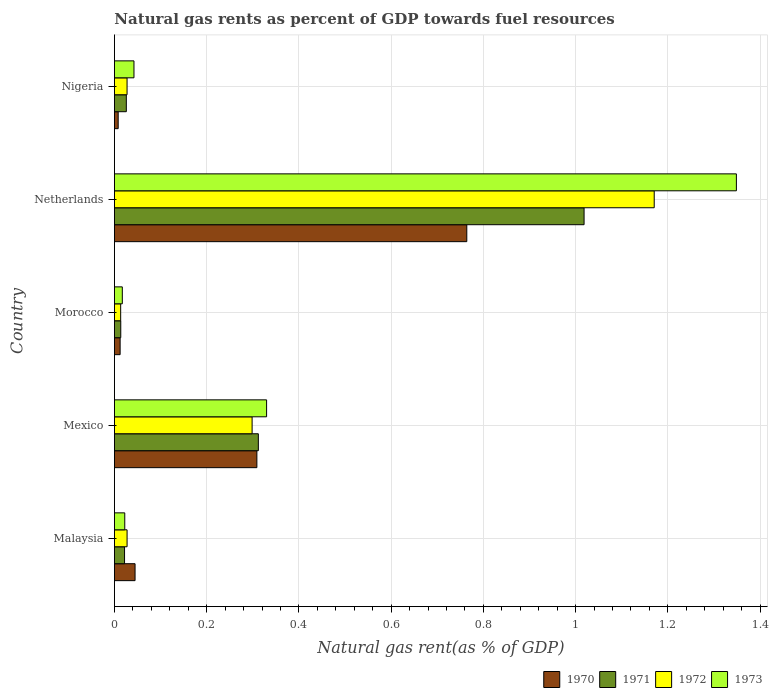Are the number of bars per tick equal to the number of legend labels?
Your answer should be very brief. Yes. How many bars are there on the 1st tick from the top?
Make the answer very short. 4. What is the natural gas rent in 1972 in Morocco?
Provide a short and direct response. 0.01. Across all countries, what is the maximum natural gas rent in 1971?
Provide a succinct answer. 1.02. Across all countries, what is the minimum natural gas rent in 1972?
Your response must be concise. 0.01. In which country was the natural gas rent in 1970 minimum?
Ensure brevity in your answer.  Nigeria. What is the total natural gas rent in 1970 in the graph?
Offer a very short reply. 1.14. What is the difference between the natural gas rent in 1973 in Morocco and that in Nigeria?
Offer a very short reply. -0.03. What is the difference between the natural gas rent in 1973 in Nigeria and the natural gas rent in 1971 in Malaysia?
Your response must be concise. 0.02. What is the average natural gas rent in 1972 per country?
Ensure brevity in your answer.  0.31. What is the difference between the natural gas rent in 1970 and natural gas rent in 1973 in Nigeria?
Offer a terse response. -0.03. In how many countries, is the natural gas rent in 1972 greater than 0.24000000000000002 %?
Make the answer very short. 2. What is the ratio of the natural gas rent in 1972 in Malaysia to that in Mexico?
Provide a short and direct response. 0.09. Is the difference between the natural gas rent in 1970 in Malaysia and Netherlands greater than the difference between the natural gas rent in 1973 in Malaysia and Netherlands?
Provide a short and direct response. Yes. What is the difference between the highest and the second highest natural gas rent in 1972?
Offer a terse response. 0.87. What is the difference between the highest and the lowest natural gas rent in 1972?
Provide a succinct answer. 1.16. Is it the case that in every country, the sum of the natural gas rent in 1971 and natural gas rent in 1973 is greater than the sum of natural gas rent in 1970 and natural gas rent in 1972?
Offer a terse response. No. Is it the case that in every country, the sum of the natural gas rent in 1973 and natural gas rent in 1972 is greater than the natural gas rent in 1971?
Give a very brief answer. Yes. How many bars are there?
Give a very brief answer. 20. Are all the bars in the graph horizontal?
Make the answer very short. Yes. How many countries are there in the graph?
Keep it short and to the point. 5. What is the difference between two consecutive major ticks on the X-axis?
Keep it short and to the point. 0.2. Does the graph contain any zero values?
Your answer should be compact. No. Does the graph contain grids?
Your answer should be very brief. Yes. How many legend labels are there?
Give a very brief answer. 4. What is the title of the graph?
Ensure brevity in your answer.  Natural gas rents as percent of GDP towards fuel resources. Does "1964" appear as one of the legend labels in the graph?
Your response must be concise. No. What is the label or title of the X-axis?
Make the answer very short. Natural gas rent(as % of GDP). What is the Natural gas rent(as % of GDP) of 1970 in Malaysia?
Give a very brief answer. 0.04. What is the Natural gas rent(as % of GDP) of 1971 in Malaysia?
Your answer should be compact. 0.02. What is the Natural gas rent(as % of GDP) of 1972 in Malaysia?
Keep it short and to the point. 0.03. What is the Natural gas rent(as % of GDP) of 1973 in Malaysia?
Give a very brief answer. 0.02. What is the Natural gas rent(as % of GDP) in 1970 in Mexico?
Your response must be concise. 0.31. What is the Natural gas rent(as % of GDP) of 1971 in Mexico?
Make the answer very short. 0.31. What is the Natural gas rent(as % of GDP) in 1972 in Mexico?
Ensure brevity in your answer.  0.3. What is the Natural gas rent(as % of GDP) in 1973 in Mexico?
Provide a short and direct response. 0.33. What is the Natural gas rent(as % of GDP) in 1970 in Morocco?
Ensure brevity in your answer.  0.01. What is the Natural gas rent(as % of GDP) of 1971 in Morocco?
Make the answer very short. 0.01. What is the Natural gas rent(as % of GDP) in 1972 in Morocco?
Provide a succinct answer. 0.01. What is the Natural gas rent(as % of GDP) of 1973 in Morocco?
Your answer should be very brief. 0.02. What is the Natural gas rent(as % of GDP) in 1970 in Netherlands?
Offer a terse response. 0.76. What is the Natural gas rent(as % of GDP) of 1971 in Netherlands?
Provide a short and direct response. 1.02. What is the Natural gas rent(as % of GDP) in 1972 in Netherlands?
Give a very brief answer. 1.17. What is the Natural gas rent(as % of GDP) of 1973 in Netherlands?
Offer a terse response. 1.35. What is the Natural gas rent(as % of GDP) of 1970 in Nigeria?
Make the answer very short. 0.01. What is the Natural gas rent(as % of GDP) in 1971 in Nigeria?
Give a very brief answer. 0.03. What is the Natural gas rent(as % of GDP) in 1972 in Nigeria?
Your answer should be compact. 0.03. What is the Natural gas rent(as % of GDP) of 1973 in Nigeria?
Provide a short and direct response. 0.04. Across all countries, what is the maximum Natural gas rent(as % of GDP) in 1970?
Offer a very short reply. 0.76. Across all countries, what is the maximum Natural gas rent(as % of GDP) in 1971?
Offer a terse response. 1.02. Across all countries, what is the maximum Natural gas rent(as % of GDP) in 1972?
Offer a very short reply. 1.17. Across all countries, what is the maximum Natural gas rent(as % of GDP) in 1973?
Your answer should be compact. 1.35. Across all countries, what is the minimum Natural gas rent(as % of GDP) of 1970?
Your answer should be very brief. 0.01. Across all countries, what is the minimum Natural gas rent(as % of GDP) in 1971?
Make the answer very short. 0.01. Across all countries, what is the minimum Natural gas rent(as % of GDP) in 1972?
Your answer should be compact. 0.01. Across all countries, what is the minimum Natural gas rent(as % of GDP) of 1973?
Provide a succinct answer. 0.02. What is the total Natural gas rent(as % of GDP) of 1970 in the graph?
Your response must be concise. 1.14. What is the total Natural gas rent(as % of GDP) in 1971 in the graph?
Offer a terse response. 1.39. What is the total Natural gas rent(as % of GDP) in 1972 in the graph?
Your answer should be very brief. 1.54. What is the total Natural gas rent(as % of GDP) of 1973 in the graph?
Provide a succinct answer. 1.76. What is the difference between the Natural gas rent(as % of GDP) of 1970 in Malaysia and that in Mexico?
Offer a terse response. -0.26. What is the difference between the Natural gas rent(as % of GDP) in 1971 in Malaysia and that in Mexico?
Your response must be concise. -0.29. What is the difference between the Natural gas rent(as % of GDP) of 1972 in Malaysia and that in Mexico?
Your answer should be compact. -0.27. What is the difference between the Natural gas rent(as % of GDP) in 1973 in Malaysia and that in Mexico?
Keep it short and to the point. -0.31. What is the difference between the Natural gas rent(as % of GDP) in 1970 in Malaysia and that in Morocco?
Make the answer very short. 0.03. What is the difference between the Natural gas rent(as % of GDP) of 1971 in Malaysia and that in Morocco?
Your response must be concise. 0.01. What is the difference between the Natural gas rent(as % of GDP) of 1972 in Malaysia and that in Morocco?
Your answer should be very brief. 0.01. What is the difference between the Natural gas rent(as % of GDP) in 1973 in Malaysia and that in Morocco?
Provide a succinct answer. 0.01. What is the difference between the Natural gas rent(as % of GDP) in 1970 in Malaysia and that in Netherlands?
Provide a short and direct response. -0.72. What is the difference between the Natural gas rent(as % of GDP) of 1971 in Malaysia and that in Netherlands?
Offer a terse response. -1. What is the difference between the Natural gas rent(as % of GDP) in 1972 in Malaysia and that in Netherlands?
Give a very brief answer. -1.14. What is the difference between the Natural gas rent(as % of GDP) of 1973 in Malaysia and that in Netherlands?
Your response must be concise. -1.33. What is the difference between the Natural gas rent(as % of GDP) of 1970 in Malaysia and that in Nigeria?
Your response must be concise. 0.04. What is the difference between the Natural gas rent(as % of GDP) of 1971 in Malaysia and that in Nigeria?
Your response must be concise. -0. What is the difference between the Natural gas rent(as % of GDP) of 1973 in Malaysia and that in Nigeria?
Your response must be concise. -0.02. What is the difference between the Natural gas rent(as % of GDP) of 1970 in Mexico and that in Morocco?
Provide a succinct answer. 0.3. What is the difference between the Natural gas rent(as % of GDP) of 1971 in Mexico and that in Morocco?
Provide a succinct answer. 0.3. What is the difference between the Natural gas rent(as % of GDP) in 1972 in Mexico and that in Morocco?
Keep it short and to the point. 0.28. What is the difference between the Natural gas rent(as % of GDP) of 1973 in Mexico and that in Morocco?
Ensure brevity in your answer.  0.31. What is the difference between the Natural gas rent(as % of GDP) in 1970 in Mexico and that in Netherlands?
Offer a terse response. -0.46. What is the difference between the Natural gas rent(as % of GDP) of 1971 in Mexico and that in Netherlands?
Provide a succinct answer. -0.71. What is the difference between the Natural gas rent(as % of GDP) of 1972 in Mexico and that in Netherlands?
Provide a short and direct response. -0.87. What is the difference between the Natural gas rent(as % of GDP) of 1973 in Mexico and that in Netherlands?
Provide a short and direct response. -1.02. What is the difference between the Natural gas rent(as % of GDP) of 1970 in Mexico and that in Nigeria?
Offer a terse response. 0.3. What is the difference between the Natural gas rent(as % of GDP) of 1971 in Mexico and that in Nigeria?
Make the answer very short. 0.29. What is the difference between the Natural gas rent(as % of GDP) in 1972 in Mexico and that in Nigeria?
Provide a succinct answer. 0.27. What is the difference between the Natural gas rent(as % of GDP) in 1973 in Mexico and that in Nigeria?
Offer a very short reply. 0.29. What is the difference between the Natural gas rent(as % of GDP) of 1970 in Morocco and that in Netherlands?
Provide a succinct answer. -0.75. What is the difference between the Natural gas rent(as % of GDP) in 1971 in Morocco and that in Netherlands?
Your answer should be compact. -1. What is the difference between the Natural gas rent(as % of GDP) of 1972 in Morocco and that in Netherlands?
Give a very brief answer. -1.16. What is the difference between the Natural gas rent(as % of GDP) in 1973 in Morocco and that in Netherlands?
Offer a terse response. -1.33. What is the difference between the Natural gas rent(as % of GDP) in 1970 in Morocco and that in Nigeria?
Ensure brevity in your answer.  0. What is the difference between the Natural gas rent(as % of GDP) in 1971 in Morocco and that in Nigeria?
Give a very brief answer. -0.01. What is the difference between the Natural gas rent(as % of GDP) of 1972 in Morocco and that in Nigeria?
Your response must be concise. -0.01. What is the difference between the Natural gas rent(as % of GDP) of 1973 in Morocco and that in Nigeria?
Your response must be concise. -0.03. What is the difference between the Natural gas rent(as % of GDP) in 1970 in Netherlands and that in Nigeria?
Provide a succinct answer. 0.76. What is the difference between the Natural gas rent(as % of GDP) of 1971 in Netherlands and that in Nigeria?
Provide a succinct answer. 0.99. What is the difference between the Natural gas rent(as % of GDP) of 1972 in Netherlands and that in Nigeria?
Provide a short and direct response. 1.14. What is the difference between the Natural gas rent(as % of GDP) in 1973 in Netherlands and that in Nigeria?
Offer a very short reply. 1.31. What is the difference between the Natural gas rent(as % of GDP) of 1970 in Malaysia and the Natural gas rent(as % of GDP) of 1971 in Mexico?
Ensure brevity in your answer.  -0.27. What is the difference between the Natural gas rent(as % of GDP) in 1970 in Malaysia and the Natural gas rent(as % of GDP) in 1972 in Mexico?
Your answer should be very brief. -0.25. What is the difference between the Natural gas rent(as % of GDP) of 1970 in Malaysia and the Natural gas rent(as % of GDP) of 1973 in Mexico?
Give a very brief answer. -0.29. What is the difference between the Natural gas rent(as % of GDP) of 1971 in Malaysia and the Natural gas rent(as % of GDP) of 1972 in Mexico?
Give a very brief answer. -0.28. What is the difference between the Natural gas rent(as % of GDP) of 1971 in Malaysia and the Natural gas rent(as % of GDP) of 1973 in Mexico?
Make the answer very short. -0.31. What is the difference between the Natural gas rent(as % of GDP) of 1972 in Malaysia and the Natural gas rent(as % of GDP) of 1973 in Mexico?
Your answer should be compact. -0.3. What is the difference between the Natural gas rent(as % of GDP) in 1970 in Malaysia and the Natural gas rent(as % of GDP) in 1971 in Morocco?
Make the answer very short. 0.03. What is the difference between the Natural gas rent(as % of GDP) in 1970 in Malaysia and the Natural gas rent(as % of GDP) in 1972 in Morocco?
Keep it short and to the point. 0.03. What is the difference between the Natural gas rent(as % of GDP) in 1970 in Malaysia and the Natural gas rent(as % of GDP) in 1973 in Morocco?
Your response must be concise. 0.03. What is the difference between the Natural gas rent(as % of GDP) of 1971 in Malaysia and the Natural gas rent(as % of GDP) of 1972 in Morocco?
Offer a terse response. 0.01. What is the difference between the Natural gas rent(as % of GDP) in 1971 in Malaysia and the Natural gas rent(as % of GDP) in 1973 in Morocco?
Provide a short and direct response. 0. What is the difference between the Natural gas rent(as % of GDP) of 1972 in Malaysia and the Natural gas rent(as % of GDP) of 1973 in Morocco?
Offer a very short reply. 0.01. What is the difference between the Natural gas rent(as % of GDP) of 1970 in Malaysia and the Natural gas rent(as % of GDP) of 1971 in Netherlands?
Your answer should be very brief. -0.97. What is the difference between the Natural gas rent(as % of GDP) in 1970 in Malaysia and the Natural gas rent(as % of GDP) in 1972 in Netherlands?
Keep it short and to the point. -1.13. What is the difference between the Natural gas rent(as % of GDP) in 1970 in Malaysia and the Natural gas rent(as % of GDP) in 1973 in Netherlands?
Ensure brevity in your answer.  -1.3. What is the difference between the Natural gas rent(as % of GDP) of 1971 in Malaysia and the Natural gas rent(as % of GDP) of 1972 in Netherlands?
Your answer should be compact. -1.15. What is the difference between the Natural gas rent(as % of GDP) of 1971 in Malaysia and the Natural gas rent(as % of GDP) of 1973 in Netherlands?
Provide a succinct answer. -1.33. What is the difference between the Natural gas rent(as % of GDP) in 1972 in Malaysia and the Natural gas rent(as % of GDP) in 1973 in Netherlands?
Your answer should be compact. -1.32. What is the difference between the Natural gas rent(as % of GDP) in 1970 in Malaysia and the Natural gas rent(as % of GDP) in 1971 in Nigeria?
Keep it short and to the point. 0.02. What is the difference between the Natural gas rent(as % of GDP) of 1970 in Malaysia and the Natural gas rent(as % of GDP) of 1972 in Nigeria?
Your answer should be compact. 0.02. What is the difference between the Natural gas rent(as % of GDP) in 1970 in Malaysia and the Natural gas rent(as % of GDP) in 1973 in Nigeria?
Your answer should be compact. 0. What is the difference between the Natural gas rent(as % of GDP) in 1971 in Malaysia and the Natural gas rent(as % of GDP) in 1972 in Nigeria?
Give a very brief answer. -0.01. What is the difference between the Natural gas rent(as % of GDP) in 1971 in Malaysia and the Natural gas rent(as % of GDP) in 1973 in Nigeria?
Offer a terse response. -0.02. What is the difference between the Natural gas rent(as % of GDP) of 1972 in Malaysia and the Natural gas rent(as % of GDP) of 1973 in Nigeria?
Your answer should be very brief. -0.01. What is the difference between the Natural gas rent(as % of GDP) in 1970 in Mexico and the Natural gas rent(as % of GDP) in 1971 in Morocco?
Make the answer very short. 0.3. What is the difference between the Natural gas rent(as % of GDP) in 1970 in Mexico and the Natural gas rent(as % of GDP) in 1972 in Morocco?
Give a very brief answer. 0.3. What is the difference between the Natural gas rent(as % of GDP) in 1970 in Mexico and the Natural gas rent(as % of GDP) in 1973 in Morocco?
Your answer should be very brief. 0.29. What is the difference between the Natural gas rent(as % of GDP) in 1971 in Mexico and the Natural gas rent(as % of GDP) in 1972 in Morocco?
Offer a very short reply. 0.3. What is the difference between the Natural gas rent(as % of GDP) of 1971 in Mexico and the Natural gas rent(as % of GDP) of 1973 in Morocco?
Give a very brief answer. 0.29. What is the difference between the Natural gas rent(as % of GDP) of 1972 in Mexico and the Natural gas rent(as % of GDP) of 1973 in Morocco?
Offer a terse response. 0.28. What is the difference between the Natural gas rent(as % of GDP) in 1970 in Mexico and the Natural gas rent(as % of GDP) in 1971 in Netherlands?
Give a very brief answer. -0.71. What is the difference between the Natural gas rent(as % of GDP) in 1970 in Mexico and the Natural gas rent(as % of GDP) in 1972 in Netherlands?
Keep it short and to the point. -0.86. What is the difference between the Natural gas rent(as % of GDP) in 1970 in Mexico and the Natural gas rent(as % of GDP) in 1973 in Netherlands?
Provide a succinct answer. -1.04. What is the difference between the Natural gas rent(as % of GDP) in 1971 in Mexico and the Natural gas rent(as % of GDP) in 1972 in Netherlands?
Offer a terse response. -0.86. What is the difference between the Natural gas rent(as % of GDP) in 1971 in Mexico and the Natural gas rent(as % of GDP) in 1973 in Netherlands?
Offer a terse response. -1.04. What is the difference between the Natural gas rent(as % of GDP) of 1972 in Mexico and the Natural gas rent(as % of GDP) of 1973 in Netherlands?
Offer a very short reply. -1.05. What is the difference between the Natural gas rent(as % of GDP) in 1970 in Mexico and the Natural gas rent(as % of GDP) in 1971 in Nigeria?
Offer a very short reply. 0.28. What is the difference between the Natural gas rent(as % of GDP) in 1970 in Mexico and the Natural gas rent(as % of GDP) in 1972 in Nigeria?
Offer a terse response. 0.28. What is the difference between the Natural gas rent(as % of GDP) in 1970 in Mexico and the Natural gas rent(as % of GDP) in 1973 in Nigeria?
Ensure brevity in your answer.  0.27. What is the difference between the Natural gas rent(as % of GDP) in 1971 in Mexico and the Natural gas rent(as % of GDP) in 1972 in Nigeria?
Provide a short and direct response. 0.28. What is the difference between the Natural gas rent(as % of GDP) of 1971 in Mexico and the Natural gas rent(as % of GDP) of 1973 in Nigeria?
Provide a succinct answer. 0.27. What is the difference between the Natural gas rent(as % of GDP) of 1972 in Mexico and the Natural gas rent(as % of GDP) of 1973 in Nigeria?
Offer a terse response. 0.26. What is the difference between the Natural gas rent(as % of GDP) in 1970 in Morocco and the Natural gas rent(as % of GDP) in 1971 in Netherlands?
Offer a very short reply. -1.01. What is the difference between the Natural gas rent(as % of GDP) in 1970 in Morocco and the Natural gas rent(as % of GDP) in 1972 in Netherlands?
Provide a succinct answer. -1.16. What is the difference between the Natural gas rent(as % of GDP) in 1970 in Morocco and the Natural gas rent(as % of GDP) in 1973 in Netherlands?
Offer a very short reply. -1.34. What is the difference between the Natural gas rent(as % of GDP) of 1971 in Morocco and the Natural gas rent(as % of GDP) of 1972 in Netherlands?
Ensure brevity in your answer.  -1.16. What is the difference between the Natural gas rent(as % of GDP) in 1971 in Morocco and the Natural gas rent(as % of GDP) in 1973 in Netherlands?
Ensure brevity in your answer.  -1.33. What is the difference between the Natural gas rent(as % of GDP) in 1972 in Morocco and the Natural gas rent(as % of GDP) in 1973 in Netherlands?
Offer a very short reply. -1.34. What is the difference between the Natural gas rent(as % of GDP) of 1970 in Morocco and the Natural gas rent(as % of GDP) of 1971 in Nigeria?
Provide a short and direct response. -0.01. What is the difference between the Natural gas rent(as % of GDP) in 1970 in Morocco and the Natural gas rent(as % of GDP) in 1972 in Nigeria?
Ensure brevity in your answer.  -0.02. What is the difference between the Natural gas rent(as % of GDP) in 1970 in Morocco and the Natural gas rent(as % of GDP) in 1973 in Nigeria?
Your answer should be compact. -0.03. What is the difference between the Natural gas rent(as % of GDP) in 1971 in Morocco and the Natural gas rent(as % of GDP) in 1972 in Nigeria?
Make the answer very short. -0.01. What is the difference between the Natural gas rent(as % of GDP) of 1971 in Morocco and the Natural gas rent(as % of GDP) of 1973 in Nigeria?
Provide a short and direct response. -0.03. What is the difference between the Natural gas rent(as % of GDP) of 1972 in Morocco and the Natural gas rent(as % of GDP) of 1973 in Nigeria?
Offer a very short reply. -0.03. What is the difference between the Natural gas rent(as % of GDP) in 1970 in Netherlands and the Natural gas rent(as % of GDP) in 1971 in Nigeria?
Provide a succinct answer. 0.74. What is the difference between the Natural gas rent(as % of GDP) of 1970 in Netherlands and the Natural gas rent(as % of GDP) of 1972 in Nigeria?
Keep it short and to the point. 0.74. What is the difference between the Natural gas rent(as % of GDP) of 1970 in Netherlands and the Natural gas rent(as % of GDP) of 1973 in Nigeria?
Give a very brief answer. 0.72. What is the difference between the Natural gas rent(as % of GDP) of 1971 in Netherlands and the Natural gas rent(as % of GDP) of 1972 in Nigeria?
Keep it short and to the point. 0.99. What is the difference between the Natural gas rent(as % of GDP) in 1972 in Netherlands and the Natural gas rent(as % of GDP) in 1973 in Nigeria?
Make the answer very short. 1.13. What is the average Natural gas rent(as % of GDP) of 1970 per country?
Give a very brief answer. 0.23. What is the average Natural gas rent(as % of GDP) of 1971 per country?
Ensure brevity in your answer.  0.28. What is the average Natural gas rent(as % of GDP) of 1972 per country?
Provide a succinct answer. 0.31. What is the average Natural gas rent(as % of GDP) of 1973 per country?
Offer a very short reply. 0.35. What is the difference between the Natural gas rent(as % of GDP) of 1970 and Natural gas rent(as % of GDP) of 1971 in Malaysia?
Offer a terse response. 0.02. What is the difference between the Natural gas rent(as % of GDP) in 1970 and Natural gas rent(as % of GDP) in 1972 in Malaysia?
Your response must be concise. 0.02. What is the difference between the Natural gas rent(as % of GDP) of 1970 and Natural gas rent(as % of GDP) of 1973 in Malaysia?
Your response must be concise. 0.02. What is the difference between the Natural gas rent(as % of GDP) of 1971 and Natural gas rent(as % of GDP) of 1972 in Malaysia?
Keep it short and to the point. -0.01. What is the difference between the Natural gas rent(as % of GDP) in 1971 and Natural gas rent(as % of GDP) in 1973 in Malaysia?
Provide a short and direct response. -0. What is the difference between the Natural gas rent(as % of GDP) of 1972 and Natural gas rent(as % of GDP) of 1973 in Malaysia?
Your response must be concise. 0.01. What is the difference between the Natural gas rent(as % of GDP) in 1970 and Natural gas rent(as % of GDP) in 1971 in Mexico?
Keep it short and to the point. -0. What is the difference between the Natural gas rent(as % of GDP) in 1970 and Natural gas rent(as % of GDP) in 1972 in Mexico?
Your response must be concise. 0.01. What is the difference between the Natural gas rent(as % of GDP) of 1970 and Natural gas rent(as % of GDP) of 1973 in Mexico?
Keep it short and to the point. -0.02. What is the difference between the Natural gas rent(as % of GDP) in 1971 and Natural gas rent(as % of GDP) in 1972 in Mexico?
Your response must be concise. 0.01. What is the difference between the Natural gas rent(as % of GDP) of 1971 and Natural gas rent(as % of GDP) of 1973 in Mexico?
Your response must be concise. -0.02. What is the difference between the Natural gas rent(as % of GDP) in 1972 and Natural gas rent(as % of GDP) in 1973 in Mexico?
Offer a terse response. -0.03. What is the difference between the Natural gas rent(as % of GDP) in 1970 and Natural gas rent(as % of GDP) in 1971 in Morocco?
Ensure brevity in your answer.  -0. What is the difference between the Natural gas rent(as % of GDP) in 1970 and Natural gas rent(as % of GDP) in 1972 in Morocco?
Your response must be concise. -0. What is the difference between the Natural gas rent(as % of GDP) in 1970 and Natural gas rent(as % of GDP) in 1973 in Morocco?
Offer a terse response. -0. What is the difference between the Natural gas rent(as % of GDP) of 1971 and Natural gas rent(as % of GDP) of 1973 in Morocco?
Provide a short and direct response. -0. What is the difference between the Natural gas rent(as % of GDP) of 1972 and Natural gas rent(as % of GDP) of 1973 in Morocco?
Offer a terse response. -0. What is the difference between the Natural gas rent(as % of GDP) of 1970 and Natural gas rent(as % of GDP) of 1971 in Netherlands?
Offer a terse response. -0.25. What is the difference between the Natural gas rent(as % of GDP) in 1970 and Natural gas rent(as % of GDP) in 1972 in Netherlands?
Make the answer very short. -0.41. What is the difference between the Natural gas rent(as % of GDP) in 1970 and Natural gas rent(as % of GDP) in 1973 in Netherlands?
Ensure brevity in your answer.  -0.58. What is the difference between the Natural gas rent(as % of GDP) in 1971 and Natural gas rent(as % of GDP) in 1972 in Netherlands?
Ensure brevity in your answer.  -0.15. What is the difference between the Natural gas rent(as % of GDP) in 1971 and Natural gas rent(as % of GDP) in 1973 in Netherlands?
Provide a short and direct response. -0.33. What is the difference between the Natural gas rent(as % of GDP) in 1972 and Natural gas rent(as % of GDP) in 1973 in Netherlands?
Your response must be concise. -0.18. What is the difference between the Natural gas rent(as % of GDP) in 1970 and Natural gas rent(as % of GDP) in 1971 in Nigeria?
Your answer should be compact. -0.02. What is the difference between the Natural gas rent(as % of GDP) of 1970 and Natural gas rent(as % of GDP) of 1972 in Nigeria?
Your answer should be compact. -0.02. What is the difference between the Natural gas rent(as % of GDP) of 1970 and Natural gas rent(as % of GDP) of 1973 in Nigeria?
Keep it short and to the point. -0.03. What is the difference between the Natural gas rent(as % of GDP) in 1971 and Natural gas rent(as % of GDP) in 1972 in Nigeria?
Keep it short and to the point. -0. What is the difference between the Natural gas rent(as % of GDP) in 1971 and Natural gas rent(as % of GDP) in 1973 in Nigeria?
Make the answer very short. -0.02. What is the difference between the Natural gas rent(as % of GDP) of 1972 and Natural gas rent(as % of GDP) of 1973 in Nigeria?
Provide a succinct answer. -0.01. What is the ratio of the Natural gas rent(as % of GDP) in 1970 in Malaysia to that in Mexico?
Offer a very short reply. 0.14. What is the ratio of the Natural gas rent(as % of GDP) in 1971 in Malaysia to that in Mexico?
Keep it short and to the point. 0.07. What is the ratio of the Natural gas rent(as % of GDP) in 1972 in Malaysia to that in Mexico?
Offer a very short reply. 0.09. What is the ratio of the Natural gas rent(as % of GDP) of 1973 in Malaysia to that in Mexico?
Make the answer very short. 0.07. What is the ratio of the Natural gas rent(as % of GDP) in 1970 in Malaysia to that in Morocco?
Ensure brevity in your answer.  3.62. What is the ratio of the Natural gas rent(as % of GDP) in 1971 in Malaysia to that in Morocco?
Ensure brevity in your answer.  1.6. What is the ratio of the Natural gas rent(as % of GDP) of 1972 in Malaysia to that in Morocco?
Offer a very short reply. 2.03. What is the ratio of the Natural gas rent(as % of GDP) of 1973 in Malaysia to that in Morocco?
Your answer should be very brief. 1.31. What is the ratio of the Natural gas rent(as % of GDP) in 1970 in Malaysia to that in Netherlands?
Keep it short and to the point. 0.06. What is the ratio of the Natural gas rent(as % of GDP) of 1971 in Malaysia to that in Netherlands?
Make the answer very short. 0.02. What is the ratio of the Natural gas rent(as % of GDP) of 1972 in Malaysia to that in Netherlands?
Keep it short and to the point. 0.02. What is the ratio of the Natural gas rent(as % of GDP) of 1973 in Malaysia to that in Netherlands?
Give a very brief answer. 0.02. What is the ratio of the Natural gas rent(as % of GDP) in 1970 in Malaysia to that in Nigeria?
Provide a short and direct response. 5.5. What is the ratio of the Natural gas rent(as % of GDP) of 1971 in Malaysia to that in Nigeria?
Offer a very short reply. 0.85. What is the ratio of the Natural gas rent(as % of GDP) in 1973 in Malaysia to that in Nigeria?
Your answer should be very brief. 0.53. What is the ratio of the Natural gas rent(as % of GDP) of 1970 in Mexico to that in Morocco?
Provide a succinct answer. 25. What is the ratio of the Natural gas rent(as % of GDP) in 1971 in Mexico to that in Morocco?
Your answer should be very brief. 22.74. What is the ratio of the Natural gas rent(as % of GDP) in 1972 in Mexico to that in Morocco?
Your answer should be compact. 22.04. What is the ratio of the Natural gas rent(as % of GDP) in 1973 in Mexico to that in Morocco?
Offer a terse response. 19.3. What is the ratio of the Natural gas rent(as % of GDP) of 1970 in Mexico to that in Netherlands?
Ensure brevity in your answer.  0.4. What is the ratio of the Natural gas rent(as % of GDP) of 1971 in Mexico to that in Netherlands?
Your response must be concise. 0.31. What is the ratio of the Natural gas rent(as % of GDP) in 1972 in Mexico to that in Netherlands?
Offer a terse response. 0.26. What is the ratio of the Natural gas rent(as % of GDP) in 1973 in Mexico to that in Netherlands?
Ensure brevity in your answer.  0.24. What is the ratio of the Natural gas rent(as % of GDP) in 1970 in Mexico to that in Nigeria?
Your response must be concise. 37.97. What is the ratio of the Natural gas rent(as % of GDP) of 1971 in Mexico to that in Nigeria?
Provide a short and direct response. 12.1. What is the ratio of the Natural gas rent(as % of GDP) of 1972 in Mexico to that in Nigeria?
Your answer should be compact. 10.89. What is the ratio of the Natural gas rent(as % of GDP) in 1973 in Mexico to that in Nigeria?
Ensure brevity in your answer.  7.79. What is the ratio of the Natural gas rent(as % of GDP) in 1970 in Morocco to that in Netherlands?
Keep it short and to the point. 0.02. What is the ratio of the Natural gas rent(as % of GDP) in 1971 in Morocco to that in Netherlands?
Keep it short and to the point. 0.01. What is the ratio of the Natural gas rent(as % of GDP) in 1972 in Morocco to that in Netherlands?
Offer a very short reply. 0.01. What is the ratio of the Natural gas rent(as % of GDP) in 1973 in Morocco to that in Netherlands?
Provide a succinct answer. 0.01. What is the ratio of the Natural gas rent(as % of GDP) in 1970 in Morocco to that in Nigeria?
Provide a short and direct response. 1.52. What is the ratio of the Natural gas rent(as % of GDP) of 1971 in Morocco to that in Nigeria?
Your answer should be compact. 0.53. What is the ratio of the Natural gas rent(as % of GDP) of 1972 in Morocco to that in Nigeria?
Offer a terse response. 0.49. What is the ratio of the Natural gas rent(as % of GDP) of 1973 in Morocco to that in Nigeria?
Provide a short and direct response. 0.4. What is the ratio of the Natural gas rent(as % of GDP) of 1970 in Netherlands to that in Nigeria?
Your answer should be very brief. 93.94. What is the ratio of the Natural gas rent(as % of GDP) in 1971 in Netherlands to that in Nigeria?
Offer a terse response. 39.48. What is the ratio of the Natural gas rent(as % of GDP) of 1972 in Netherlands to that in Nigeria?
Provide a succinct answer. 42.7. What is the ratio of the Natural gas rent(as % of GDP) in 1973 in Netherlands to that in Nigeria?
Make the answer very short. 31.84. What is the difference between the highest and the second highest Natural gas rent(as % of GDP) in 1970?
Keep it short and to the point. 0.46. What is the difference between the highest and the second highest Natural gas rent(as % of GDP) in 1971?
Your response must be concise. 0.71. What is the difference between the highest and the second highest Natural gas rent(as % of GDP) of 1972?
Ensure brevity in your answer.  0.87. What is the difference between the highest and the second highest Natural gas rent(as % of GDP) in 1973?
Offer a very short reply. 1.02. What is the difference between the highest and the lowest Natural gas rent(as % of GDP) of 1970?
Ensure brevity in your answer.  0.76. What is the difference between the highest and the lowest Natural gas rent(as % of GDP) in 1971?
Provide a short and direct response. 1. What is the difference between the highest and the lowest Natural gas rent(as % of GDP) in 1972?
Offer a terse response. 1.16. What is the difference between the highest and the lowest Natural gas rent(as % of GDP) in 1973?
Provide a succinct answer. 1.33. 